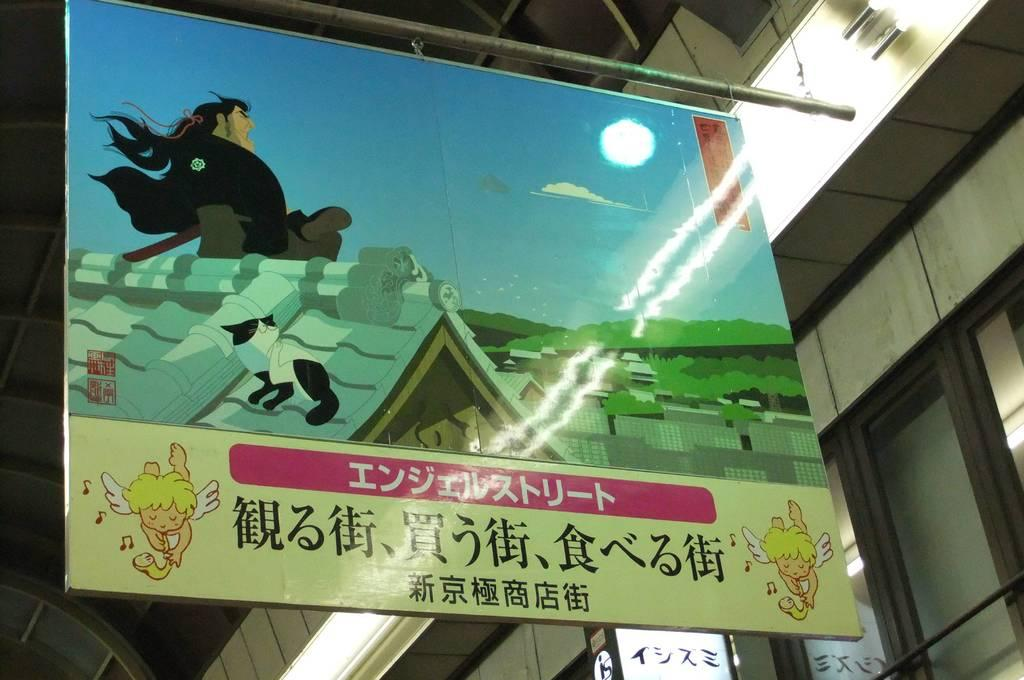What is the main object in the image? There is a board in the image. What can be found on the board? The board contains a depiction of a man, a cat, a house, and the sky. Are there any other objects visible in the image? Yes, there is a rod and windows in the image. What type of potato is being used to clean the windows in the image? There is no potato present in the image, and the windows are not being cleaned. Can you tell me how many tubes of toothpaste are on the board in the image? There are no tubes of toothpaste present on the board or in the image. 